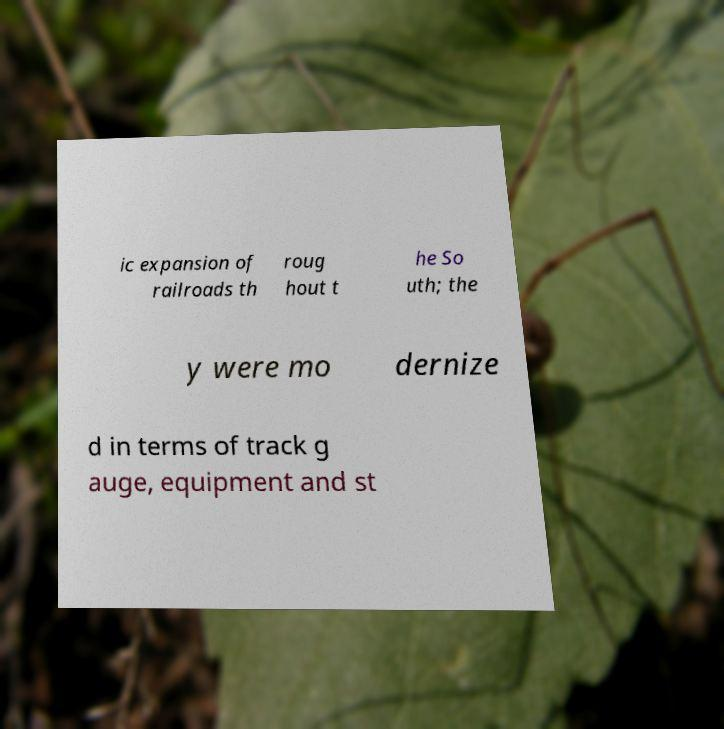I need the written content from this picture converted into text. Can you do that? ic expansion of railroads th roug hout t he So uth; the y were mo dernize d in terms of track g auge, equipment and st 